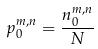Convert formula to latex. <formula><loc_0><loc_0><loc_500><loc_500>p _ { 0 } ^ { m , n } = \frac { n _ { 0 } ^ { m , n } } { N }</formula> 